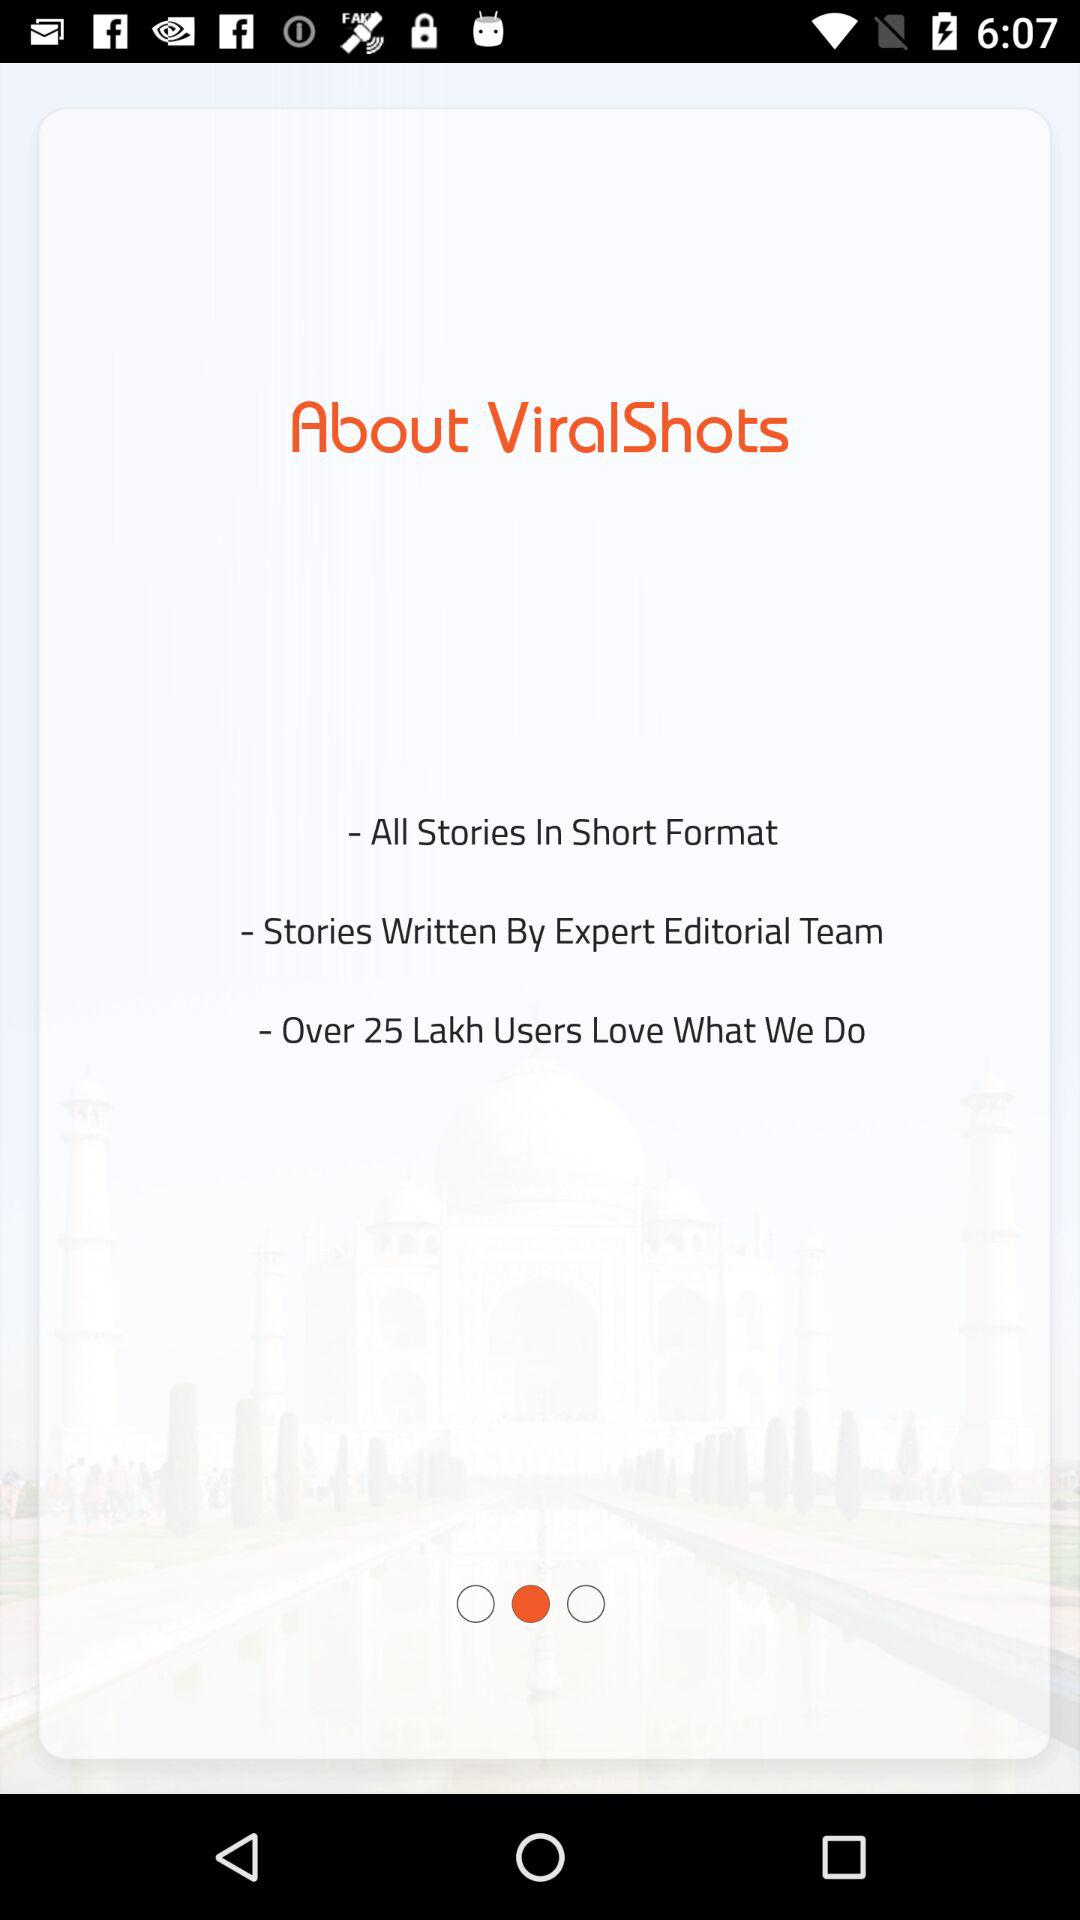How many users loved this application? There are over 25 Lakh users who love this application. 